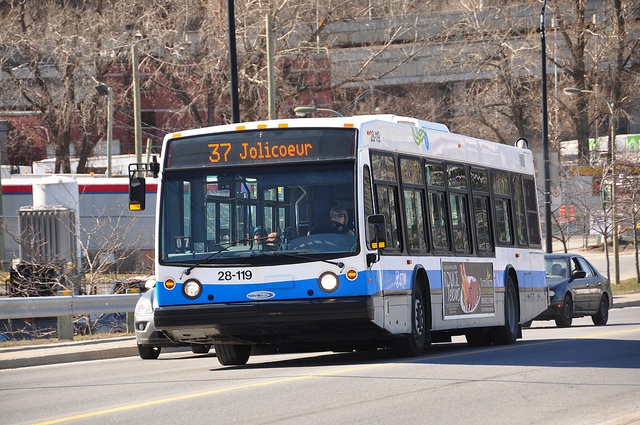Describe the objects in this image and their specific colors. I can see bus in gray, black, lightgray, and navy tones, car in gray, black, and darkgray tones, car in gray, black, white, and darkgray tones, people in gray, black, and darkblue tones, and people in gray, navy, black, and blue tones in this image. 